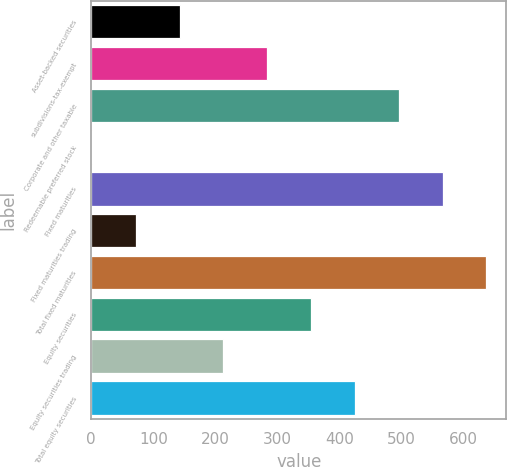Convert chart to OTSL. <chart><loc_0><loc_0><loc_500><loc_500><bar_chart><fcel>Asset-backed securities<fcel>subdivisions-tax-exempt<fcel>Corporate and other taxable<fcel>Redeemable preferred stock<fcel>Fixed maturities<fcel>Fixed maturities trading<fcel>Total fixed maturities<fcel>Equity securities<fcel>Equity securities trading<fcel>Total equity securities<nl><fcel>142.2<fcel>283.4<fcel>495.2<fcel>1<fcel>565.8<fcel>71.6<fcel>636.4<fcel>354<fcel>212.8<fcel>424.6<nl></chart> 